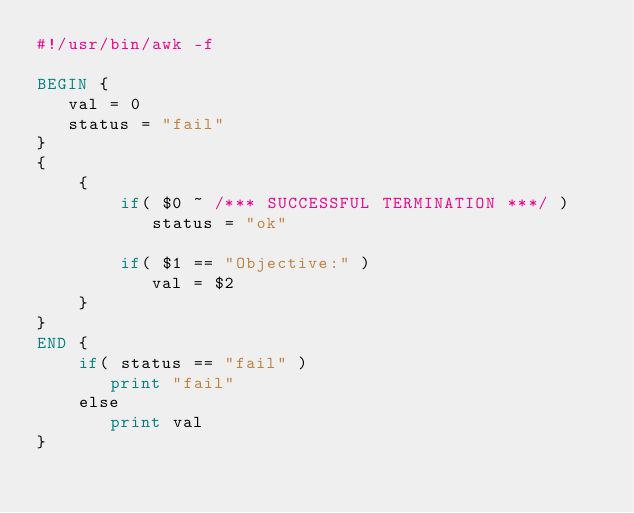<code> <loc_0><loc_0><loc_500><loc_500><_Awk_>#!/usr/bin/awk -f

BEGIN { 
   val = 0
   status = "fail"
} 
{
    { 
        if( $0 ~ /*** SUCCESSFUL TERMINATION ***/ )
           status = "ok"
            
        if( $1 == "Objective:" )    
           val = $2
    }
}
END {
    if( status == "fail" ) 
       print "fail"
    else
       print val
}</code> 